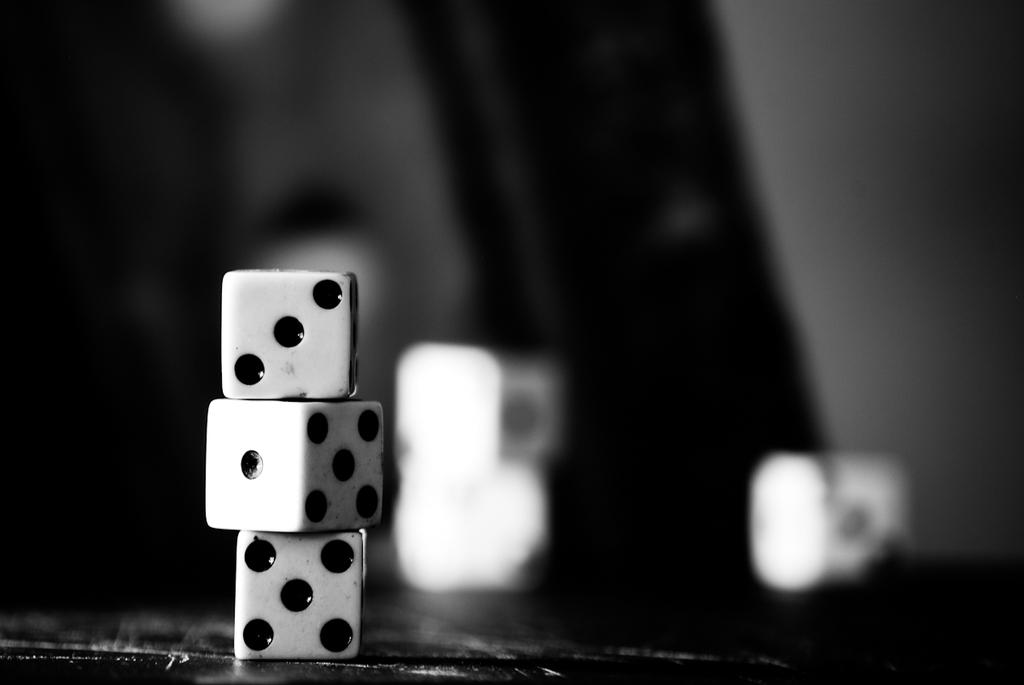What is the color scheme of the image? The image is black and white. What objects can be seen in the image? There are dice in the image. Can you describe the background of the image? The background of the image is blurred. How many tails can be seen on the dice in the image? There are no tails present on the dice in the image, as dice do not have tails. 